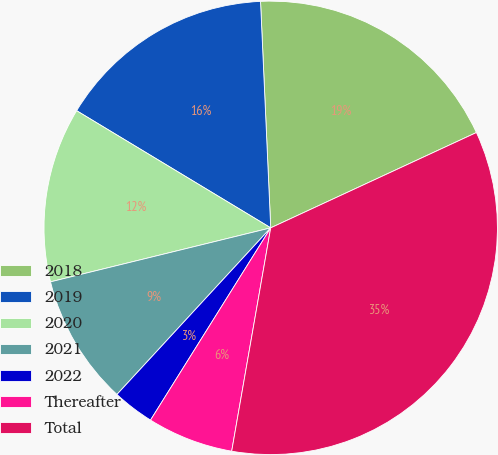<chart> <loc_0><loc_0><loc_500><loc_500><pie_chart><fcel>2018<fcel>2019<fcel>2020<fcel>2021<fcel>2022<fcel>Thereafter<fcel>Total<nl><fcel>18.81%<fcel>15.64%<fcel>12.47%<fcel>9.31%<fcel>2.97%<fcel>6.14%<fcel>34.66%<nl></chart> 